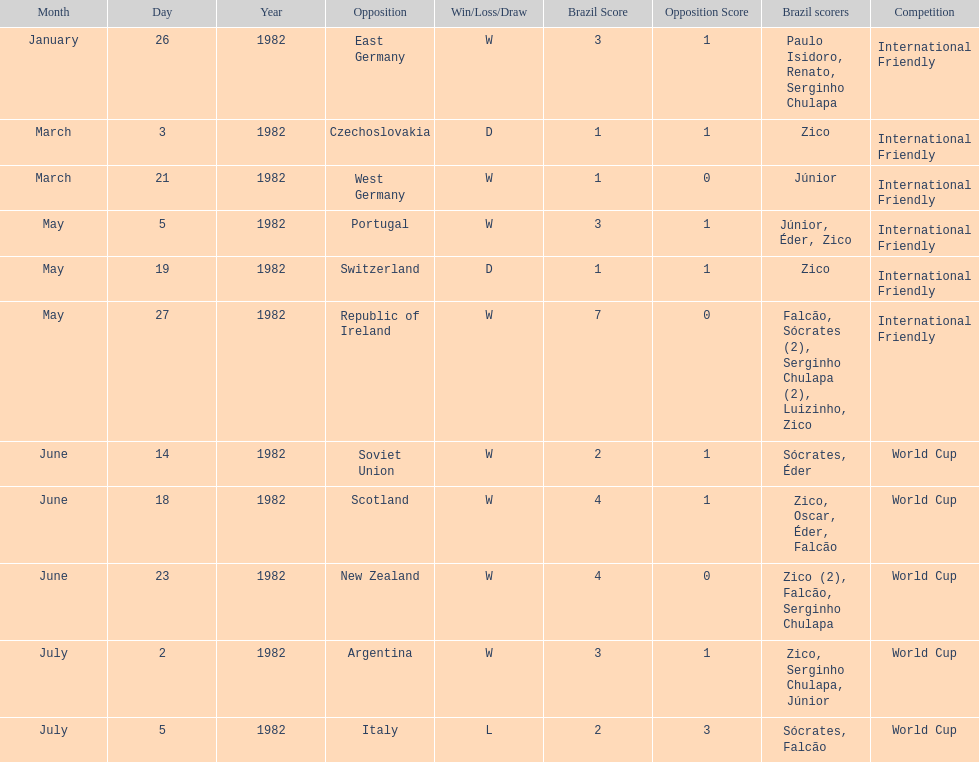How many games did this team play in 1982? 11. Could you help me parse every detail presented in this table? {'header': ['Month', 'Day', 'Year', 'Opposition', 'Win/Loss/Draw', 'Brazil Score', 'Opposition Score', 'Brazil scorers', 'Competition'], 'rows': [['January', '26', '1982', 'East Germany', 'W', '3', '1', 'Paulo Isidoro, Renato, Serginho Chulapa', 'International Friendly'], ['March', '3', '1982', 'Czechoslovakia', 'D', '1', '1', 'Zico', 'International Friendly'], ['March', '21', '1982', 'West Germany', 'W', '1', '0', 'Júnior', 'International Friendly'], ['May', '5', '1982', 'Portugal', 'W', '3', '1', 'Júnior, Éder, Zico', 'International Friendly'], ['May', '19', '1982', 'Switzerland', 'D', '1', '1', 'Zico', 'International Friendly'], ['May', '27', '1982', 'Republic of Ireland', 'W', '7', '0', 'Falcão, Sócrates (2), Serginho Chulapa (2), Luizinho, Zico', 'International Friendly'], ['June', '14', '1982', 'Soviet Union', 'W', '2', '1', 'Sócrates, Éder', 'World Cup'], ['June', '18', '1982', 'Scotland', 'W', '4', '1', 'Zico, Oscar, Éder, Falcão', 'World Cup'], ['June', '23', '1982', 'New Zealand', 'W', '4', '0', 'Zico (2), Falcão, Serginho Chulapa', 'World Cup'], ['July', '2', '1982', 'Argentina', 'W', '3', '1', 'Zico, Serginho Chulapa, Júnior', 'World Cup'], ['July', '5', '1982', 'Italy', 'L', '2', '3', 'Sócrates, Falcão', 'World Cup']]} 